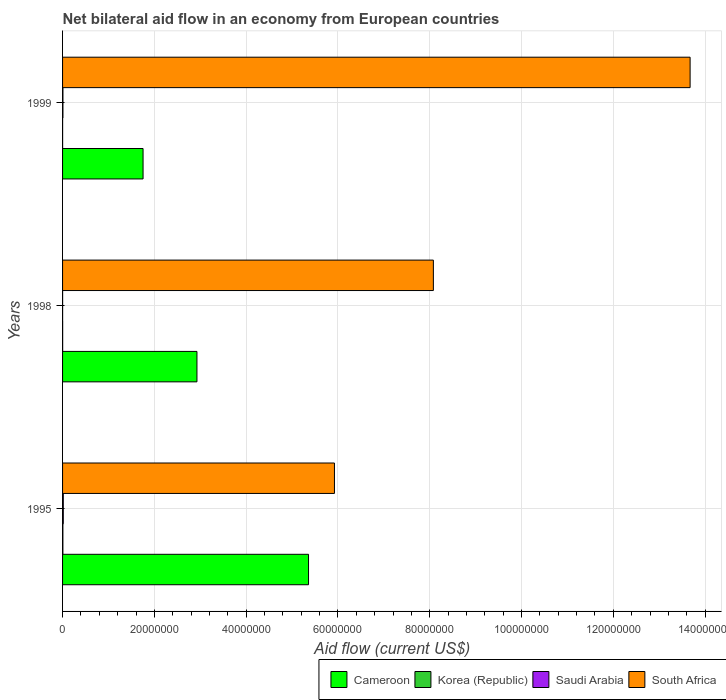How many different coloured bars are there?
Offer a very short reply. 4. How many groups of bars are there?
Your answer should be very brief. 3. What is the label of the 3rd group of bars from the top?
Offer a terse response. 1995. What is the net bilateral aid flow in South Africa in 1998?
Keep it short and to the point. 8.08e+07. Across all years, what is the minimum net bilateral aid flow in Saudi Arabia?
Give a very brief answer. 10000. In which year was the net bilateral aid flow in Cameroon maximum?
Your answer should be compact. 1995. In which year was the net bilateral aid flow in Korea (Republic) minimum?
Keep it short and to the point. 1999. What is the total net bilateral aid flow in South Africa in the graph?
Your answer should be compact. 2.77e+08. What is the average net bilateral aid flow in Cameroon per year?
Provide a succinct answer. 3.35e+07. In the year 1999, what is the difference between the net bilateral aid flow in Korea (Republic) and net bilateral aid flow in Cameroon?
Offer a terse response. -1.75e+07. In how many years, is the net bilateral aid flow in Saudi Arabia greater than 20000000 US$?
Provide a succinct answer. 0. What is the ratio of the net bilateral aid flow in South Africa in 1998 to that in 1999?
Offer a very short reply. 0.59. Is the net bilateral aid flow in Saudi Arabia in 1995 less than that in 1998?
Offer a terse response. No. Is the difference between the net bilateral aid flow in Korea (Republic) in 1995 and 1999 greater than the difference between the net bilateral aid flow in Cameroon in 1995 and 1999?
Your answer should be very brief. No. What is the difference between the highest and the second highest net bilateral aid flow in Cameroon?
Provide a succinct answer. 2.43e+07. In how many years, is the net bilateral aid flow in Cameroon greater than the average net bilateral aid flow in Cameroon taken over all years?
Give a very brief answer. 1. Is it the case that in every year, the sum of the net bilateral aid flow in Cameroon and net bilateral aid flow in Korea (Republic) is greater than the sum of net bilateral aid flow in South Africa and net bilateral aid flow in Saudi Arabia?
Your response must be concise. No. What does the 1st bar from the top in 1999 represents?
Make the answer very short. South Africa. What does the 1st bar from the bottom in 1998 represents?
Your response must be concise. Cameroon. Is it the case that in every year, the sum of the net bilateral aid flow in Korea (Republic) and net bilateral aid flow in South Africa is greater than the net bilateral aid flow in Cameroon?
Keep it short and to the point. Yes. How many bars are there?
Ensure brevity in your answer.  12. Are all the bars in the graph horizontal?
Your answer should be compact. Yes. Does the graph contain any zero values?
Ensure brevity in your answer.  No. Does the graph contain grids?
Offer a very short reply. Yes. How many legend labels are there?
Your answer should be very brief. 4. What is the title of the graph?
Offer a very short reply. Net bilateral aid flow in an economy from European countries. Does "Bhutan" appear as one of the legend labels in the graph?
Keep it short and to the point. No. What is the label or title of the X-axis?
Provide a succinct answer. Aid flow (current US$). What is the Aid flow (current US$) in Cameroon in 1995?
Provide a short and direct response. 5.36e+07. What is the Aid flow (current US$) in Korea (Republic) in 1995?
Provide a succinct answer. 7.00e+04. What is the Aid flow (current US$) in Saudi Arabia in 1995?
Offer a terse response. 1.60e+05. What is the Aid flow (current US$) in South Africa in 1995?
Keep it short and to the point. 5.92e+07. What is the Aid flow (current US$) of Cameroon in 1998?
Offer a terse response. 2.93e+07. What is the Aid flow (current US$) of South Africa in 1998?
Keep it short and to the point. 8.08e+07. What is the Aid flow (current US$) in Cameroon in 1999?
Ensure brevity in your answer.  1.75e+07. What is the Aid flow (current US$) of Saudi Arabia in 1999?
Your answer should be very brief. 8.00e+04. What is the Aid flow (current US$) of South Africa in 1999?
Provide a succinct answer. 1.37e+08. Across all years, what is the maximum Aid flow (current US$) of Cameroon?
Offer a very short reply. 5.36e+07. Across all years, what is the maximum Aid flow (current US$) in South Africa?
Give a very brief answer. 1.37e+08. Across all years, what is the minimum Aid flow (current US$) of Cameroon?
Provide a short and direct response. 1.75e+07. Across all years, what is the minimum Aid flow (current US$) of South Africa?
Provide a short and direct response. 5.92e+07. What is the total Aid flow (current US$) in Cameroon in the graph?
Keep it short and to the point. 1.00e+08. What is the total Aid flow (current US$) of Saudi Arabia in the graph?
Your answer should be very brief. 2.50e+05. What is the total Aid flow (current US$) of South Africa in the graph?
Your answer should be very brief. 2.77e+08. What is the difference between the Aid flow (current US$) in Cameroon in 1995 and that in 1998?
Your answer should be very brief. 2.43e+07. What is the difference between the Aid flow (current US$) in Korea (Republic) in 1995 and that in 1998?
Make the answer very short. 5.00e+04. What is the difference between the Aid flow (current US$) in Saudi Arabia in 1995 and that in 1998?
Your answer should be compact. 1.50e+05. What is the difference between the Aid flow (current US$) in South Africa in 1995 and that in 1998?
Your answer should be compact. -2.16e+07. What is the difference between the Aid flow (current US$) in Cameroon in 1995 and that in 1999?
Give a very brief answer. 3.60e+07. What is the difference between the Aid flow (current US$) of Saudi Arabia in 1995 and that in 1999?
Offer a terse response. 8.00e+04. What is the difference between the Aid flow (current US$) in South Africa in 1995 and that in 1999?
Ensure brevity in your answer.  -7.75e+07. What is the difference between the Aid flow (current US$) in Cameroon in 1998 and that in 1999?
Give a very brief answer. 1.17e+07. What is the difference between the Aid flow (current US$) of Korea (Republic) in 1998 and that in 1999?
Give a very brief answer. 10000. What is the difference between the Aid flow (current US$) in Saudi Arabia in 1998 and that in 1999?
Give a very brief answer. -7.00e+04. What is the difference between the Aid flow (current US$) of South Africa in 1998 and that in 1999?
Give a very brief answer. -5.59e+07. What is the difference between the Aid flow (current US$) in Cameroon in 1995 and the Aid flow (current US$) in Korea (Republic) in 1998?
Offer a very short reply. 5.36e+07. What is the difference between the Aid flow (current US$) of Cameroon in 1995 and the Aid flow (current US$) of Saudi Arabia in 1998?
Make the answer very short. 5.36e+07. What is the difference between the Aid flow (current US$) in Cameroon in 1995 and the Aid flow (current US$) in South Africa in 1998?
Keep it short and to the point. -2.72e+07. What is the difference between the Aid flow (current US$) in Korea (Republic) in 1995 and the Aid flow (current US$) in Saudi Arabia in 1998?
Your answer should be very brief. 6.00e+04. What is the difference between the Aid flow (current US$) of Korea (Republic) in 1995 and the Aid flow (current US$) of South Africa in 1998?
Offer a very short reply. -8.07e+07. What is the difference between the Aid flow (current US$) of Saudi Arabia in 1995 and the Aid flow (current US$) of South Africa in 1998?
Provide a succinct answer. -8.06e+07. What is the difference between the Aid flow (current US$) in Cameroon in 1995 and the Aid flow (current US$) in Korea (Republic) in 1999?
Provide a short and direct response. 5.36e+07. What is the difference between the Aid flow (current US$) in Cameroon in 1995 and the Aid flow (current US$) in Saudi Arabia in 1999?
Make the answer very short. 5.35e+07. What is the difference between the Aid flow (current US$) of Cameroon in 1995 and the Aid flow (current US$) of South Africa in 1999?
Your response must be concise. -8.31e+07. What is the difference between the Aid flow (current US$) in Korea (Republic) in 1995 and the Aid flow (current US$) in South Africa in 1999?
Keep it short and to the point. -1.37e+08. What is the difference between the Aid flow (current US$) of Saudi Arabia in 1995 and the Aid flow (current US$) of South Africa in 1999?
Ensure brevity in your answer.  -1.37e+08. What is the difference between the Aid flow (current US$) of Cameroon in 1998 and the Aid flow (current US$) of Korea (Republic) in 1999?
Provide a short and direct response. 2.93e+07. What is the difference between the Aid flow (current US$) in Cameroon in 1998 and the Aid flow (current US$) in Saudi Arabia in 1999?
Provide a short and direct response. 2.92e+07. What is the difference between the Aid flow (current US$) of Cameroon in 1998 and the Aid flow (current US$) of South Africa in 1999?
Ensure brevity in your answer.  -1.07e+08. What is the difference between the Aid flow (current US$) in Korea (Republic) in 1998 and the Aid flow (current US$) in Saudi Arabia in 1999?
Provide a short and direct response. -6.00e+04. What is the difference between the Aid flow (current US$) in Korea (Republic) in 1998 and the Aid flow (current US$) in South Africa in 1999?
Provide a short and direct response. -1.37e+08. What is the difference between the Aid flow (current US$) of Saudi Arabia in 1998 and the Aid flow (current US$) of South Africa in 1999?
Your answer should be very brief. -1.37e+08. What is the average Aid flow (current US$) in Cameroon per year?
Offer a terse response. 3.35e+07. What is the average Aid flow (current US$) in Korea (Republic) per year?
Provide a succinct answer. 3.33e+04. What is the average Aid flow (current US$) of Saudi Arabia per year?
Offer a very short reply. 8.33e+04. What is the average Aid flow (current US$) in South Africa per year?
Your response must be concise. 9.23e+07. In the year 1995, what is the difference between the Aid flow (current US$) in Cameroon and Aid flow (current US$) in Korea (Republic)?
Give a very brief answer. 5.35e+07. In the year 1995, what is the difference between the Aid flow (current US$) of Cameroon and Aid flow (current US$) of Saudi Arabia?
Offer a very short reply. 5.34e+07. In the year 1995, what is the difference between the Aid flow (current US$) of Cameroon and Aid flow (current US$) of South Africa?
Your answer should be very brief. -5.65e+06. In the year 1995, what is the difference between the Aid flow (current US$) in Korea (Republic) and Aid flow (current US$) in South Africa?
Your response must be concise. -5.92e+07. In the year 1995, what is the difference between the Aid flow (current US$) of Saudi Arabia and Aid flow (current US$) of South Africa?
Keep it short and to the point. -5.91e+07. In the year 1998, what is the difference between the Aid flow (current US$) of Cameroon and Aid flow (current US$) of Korea (Republic)?
Ensure brevity in your answer.  2.93e+07. In the year 1998, what is the difference between the Aid flow (current US$) of Cameroon and Aid flow (current US$) of Saudi Arabia?
Offer a very short reply. 2.93e+07. In the year 1998, what is the difference between the Aid flow (current US$) of Cameroon and Aid flow (current US$) of South Africa?
Give a very brief answer. -5.15e+07. In the year 1998, what is the difference between the Aid flow (current US$) of Korea (Republic) and Aid flow (current US$) of Saudi Arabia?
Your answer should be compact. 10000. In the year 1998, what is the difference between the Aid flow (current US$) in Korea (Republic) and Aid flow (current US$) in South Africa?
Offer a terse response. -8.08e+07. In the year 1998, what is the difference between the Aid flow (current US$) of Saudi Arabia and Aid flow (current US$) of South Africa?
Provide a short and direct response. -8.08e+07. In the year 1999, what is the difference between the Aid flow (current US$) of Cameroon and Aid flow (current US$) of Korea (Republic)?
Give a very brief answer. 1.75e+07. In the year 1999, what is the difference between the Aid flow (current US$) in Cameroon and Aid flow (current US$) in Saudi Arabia?
Provide a succinct answer. 1.75e+07. In the year 1999, what is the difference between the Aid flow (current US$) of Cameroon and Aid flow (current US$) of South Africa?
Provide a short and direct response. -1.19e+08. In the year 1999, what is the difference between the Aid flow (current US$) of Korea (Republic) and Aid flow (current US$) of Saudi Arabia?
Ensure brevity in your answer.  -7.00e+04. In the year 1999, what is the difference between the Aid flow (current US$) in Korea (Republic) and Aid flow (current US$) in South Africa?
Provide a short and direct response. -1.37e+08. In the year 1999, what is the difference between the Aid flow (current US$) in Saudi Arabia and Aid flow (current US$) in South Africa?
Offer a terse response. -1.37e+08. What is the ratio of the Aid flow (current US$) in Cameroon in 1995 to that in 1998?
Provide a succinct answer. 1.83. What is the ratio of the Aid flow (current US$) of South Africa in 1995 to that in 1998?
Make the answer very short. 0.73. What is the ratio of the Aid flow (current US$) in Cameroon in 1995 to that in 1999?
Ensure brevity in your answer.  3.06. What is the ratio of the Aid flow (current US$) in Korea (Republic) in 1995 to that in 1999?
Give a very brief answer. 7. What is the ratio of the Aid flow (current US$) of South Africa in 1995 to that in 1999?
Your response must be concise. 0.43. What is the ratio of the Aid flow (current US$) of Cameroon in 1998 to that in 1999?
Make the answer very short. 1.67. What is the ratio of the Aid flow (current US$) in Korea (Republic) in 1998 to that in 1999?
Ensure brevity in your answer.  2. What is the ratio of the Aid flow (current US$) in Saudi Arabia in 1998 to that in 1999?
Your response must be concise. 0.12. What is the ratio of the Aid flow (current US$) in South Africa in 1998 to that in 1999?
Provide a succinct answer. 0.59. What is the difference between the highest and the second highest Aid flow (current US$) of Cameroon?
Provide a short and direct response. 2.43e+07. What is the difference between the highest and the second highest Aid flow (current US$) in Korea (Republic)?
Give a very brief answer. 5.00e+04. What is the difference between the highest and the second highest Aid flow (current US$) of South Africa?
Provide a succinct answer. 5.59e+07. What is the difference between the highest and the lowest Aid flow (current US$) in Cameroon?
Give a very brief answer. 3.60e+07. What is the difference between the highest and the lowest Aid flow (current US$) of Korea (Republic)?
Offer a very short reply. 6.00e+04. What is the difference between the highest and the lowest Aid flow (current US$) in Saudi Arabia?
Your answer should be very brief. 1.50e+05. What is the difference between the highest and the lowest Aid flow (current US$) of South Africa?
Give a very brief answer. 7.75e+07. 